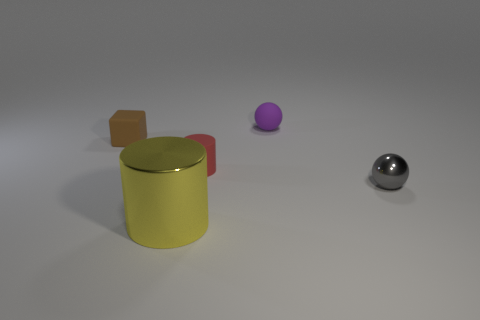Is the color of the small metallic ball the same as the big object? no 